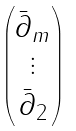<formula> <loc_0><loc_0><loc_500><loc_500>\begin{pmatrix} \bar { \partial } _ { m } \\ \vdots \\ \bar { \partial } _ { 2 } \end{pmatrix}</formula> 